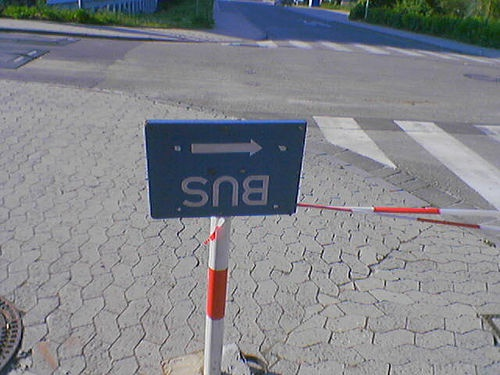Describe the objects in this image and their specific colors. I can see various objects in this image with different colors. 